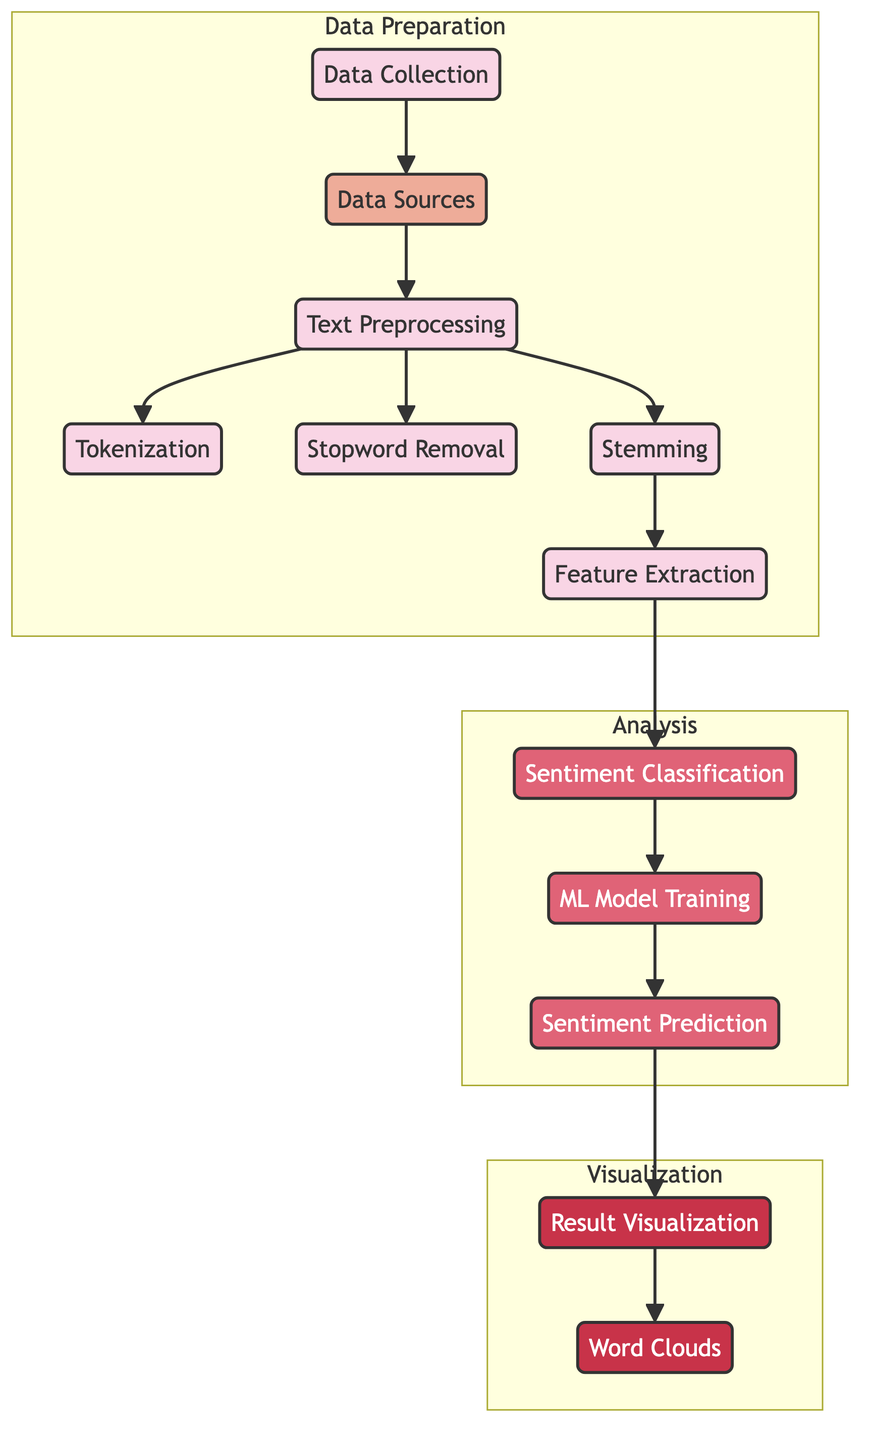What is the first step in the machine learning process depicted in the diagram? The first step in the machine learning process is "Data Collection," which is the starting point before any preprocessing or analysis can happen.
Answer: Data Collection How many preprocessing steps are illustrated in the diagram? The diagram shows three specific preprocessing steps: Tokenization, Stopword Removal, and Stemming, indicating a focused approach on text preparation.
Answer: Three Which node comes after "Feature Extraction"? The node that follows "Feature Extraction" is "Sentiment Classification," indicating that once features are extracted, they are analyzed for sentiment.
Answer: Sentiment Classification What is the final output visualization method used in the process? The final visualization method outlined in the diagram is "Word Clouds," which is a common way to represent sentiment results visually by highlighting frequently used words.
Answer: Word Clouds What subgraph contains the node "Stemming"? The node "Stemming" is part of the "Data Preparation" subgraph, which encompasses all the data-related processing before analysis.
Answer: Data Preparation Which part of the diagram focuses on the analysis of sentiment? The "Analysis" subgraph specifically focuses on sentiment analysis, where "Sentiment Classification," "ML Model Training," and "Sentiment Prediction" are included.
Answer: Analysis How many nodes are classified under the "Visualization" class in the diagram? There are two nodes classified under the "Visualization" category: "Result Visualization" and "Word Clouds," indicating the stages of visual output generation.
Answer: Two What connects "Machine Learning Model" to "Sentiment Prediction"? The connection from "Machine Learning Model" to "Sentiment Prediction" is an edge indicating that the trained model is used to make predictions based on the processed data.
Answer: An edge What is the purpose of "Stopword Removal"? The purpose of "Stopword Removal" is to eliminate common words that do not contribute to the sentiment meaning, enhancing the quality of input data for further analysis.
Answer: Eliminate common words 